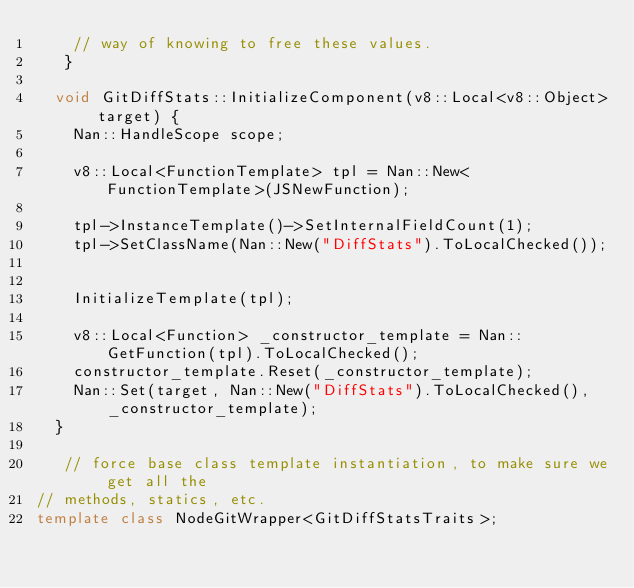<code> <loc_0><loc_0><loc_500><loc_500><_C++_>    // way of knowing to free these values.
   }

  void GitDiffStats::InitializeComponent(v8::Local<v8::Object> target) {
    Nan::HandleScope scope;

    v8::Local<FunctionTemplate> tpl = Nan::New<FunctionTemplate>(JSNewFunction);

    tpl->InstanceTemplate()->SetInternalFieldCount(1);
    tpl->SetClassName(Nan::New("DiffStats").ToLocalChecked());

  
    InitializeTemplate(tpl);

    v8::Local<Function> _constructor_template = Nan::GetFunction(tpl).ToLocalChecked();
    constructor_template.Reset(_constructor_template);
    Nan::Set(target, Nan::New("DiffStats").ToLocalChecked(), _constructor_template);
  }

   // force base class template instantiation, to make sure we get all the
// methods, statics, etc.
template class NodeGitWrapper<GitDiffStatsTraits>;
 </code> 